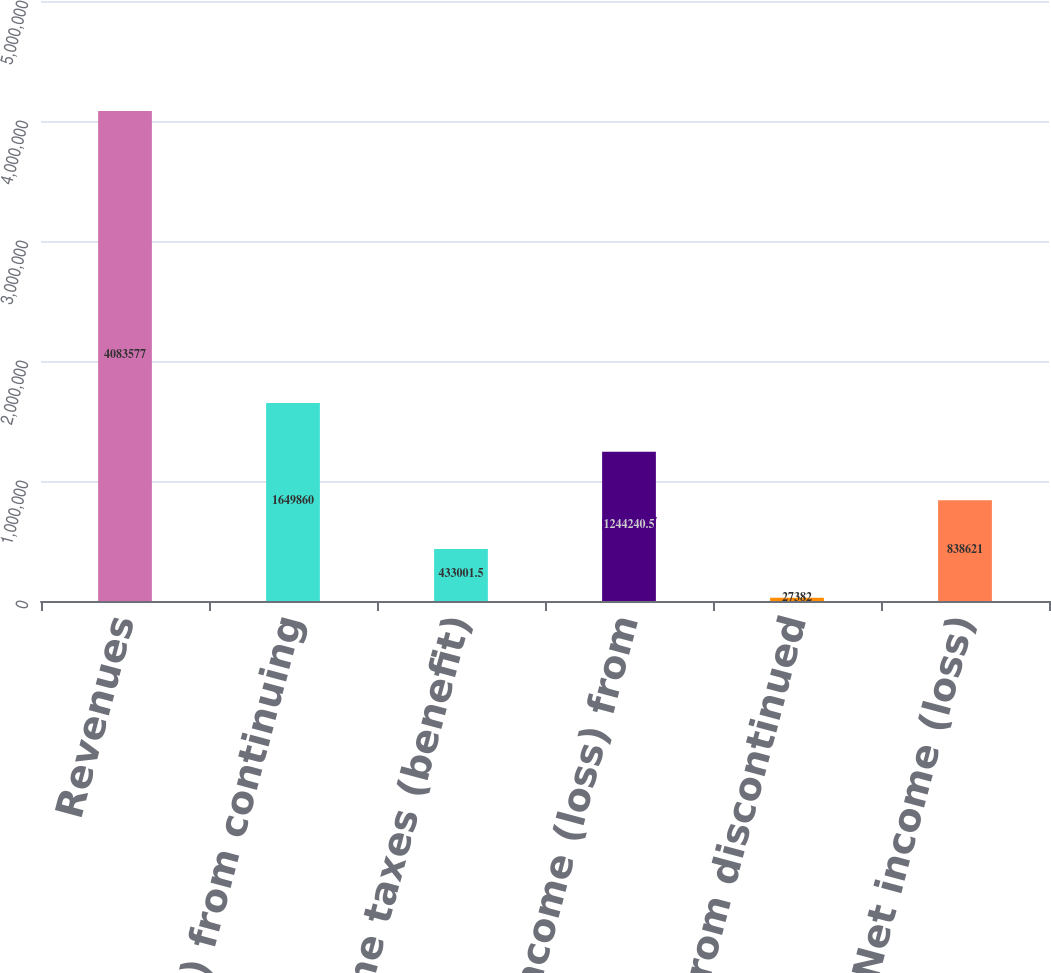Convert chart to OTSL. <chart><loc_0><loc_0><loc_500><loc_500><bar_chart><fcel>Revenues<fcel>Income (loss) from continuing<fcel>Income taxes (benefit)<fcel>Net income (loss) from<fcel>Net loss from discontinued<fcel>Net income (loss)<nl><fcel>4.08358e+06<fcel>1.64986e+06<fcel>433002<fcel>1.24424e+06<fcel>27382<fcel>838621<nl></chart> 